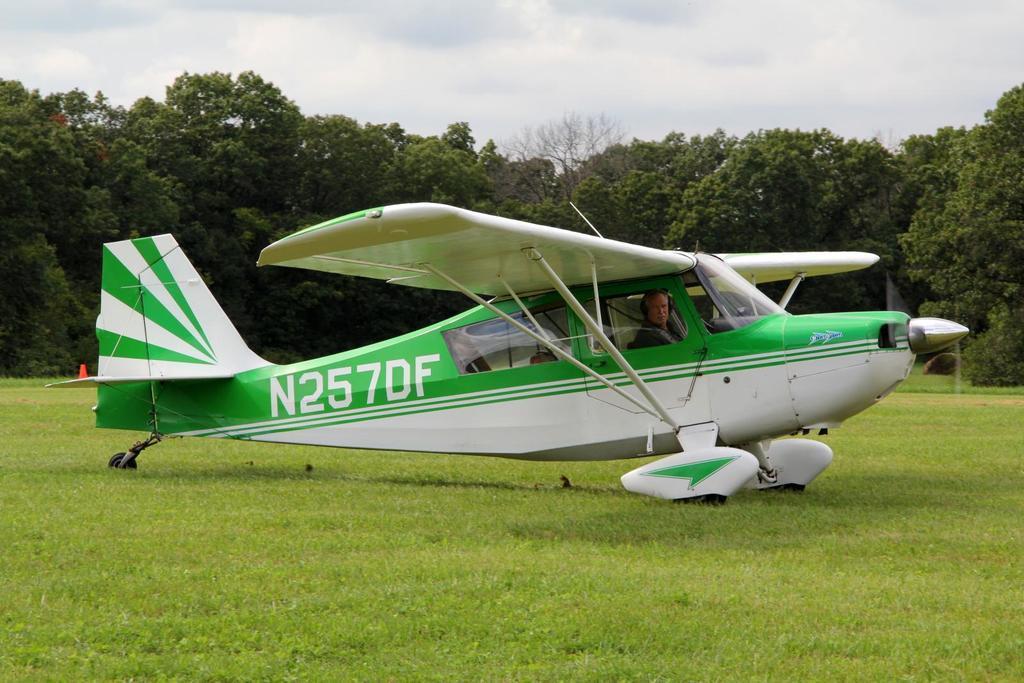Could you give a brief overview of what you see in this image? In this picture we can see an airplane, there is a person sitting in the airplane, at the bottom there is grass, inn the background we can see trees, there is the sky at the top of the picture. 